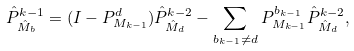<formula> <loc_0><loc_0><loc_500><loc_500>{ \hat { P } } ^ { k - 1 } _ { { \hat { M } } _ { b } } = ( I - P ^ { d } _ { M _ { k - 1 } } ) { \hat { P } } ^ { k - 2 } _ { { \hat { M } } _ { d } } - \sum _ { b _ { k - 1 } \ne d } P ^ { b _ { k - 1 } } _ { M _ { k - 1 } } { \hat { P } } ^ { k - 2 } _ { { \hat { M } } _ { d } } ,</formula> 